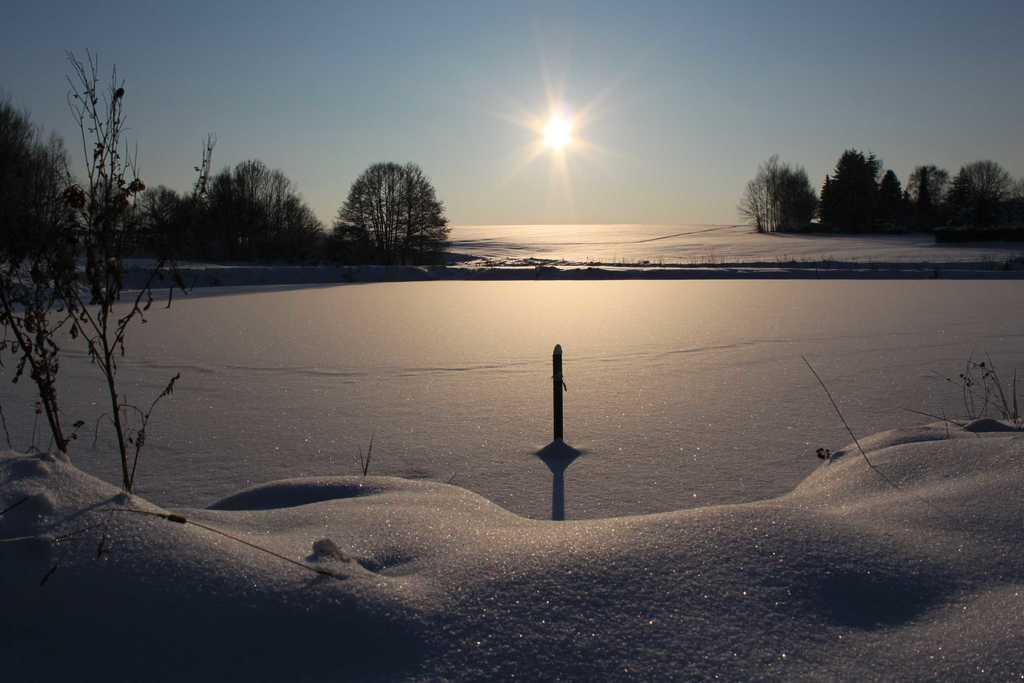What is present at the bottom of the image? There is snow at the bottom of the image. What can be seen in the background of the image? There are many trees in the background of the image. What is visible at the top of the image? The sky is visible at the top of the image. Can the sun be seen in the image? Yes, the sun is observable in the sky. How does the kitty stop the snow from falling in the image? There is no kitty present in the image, so it cannot stop the snow from falling. 